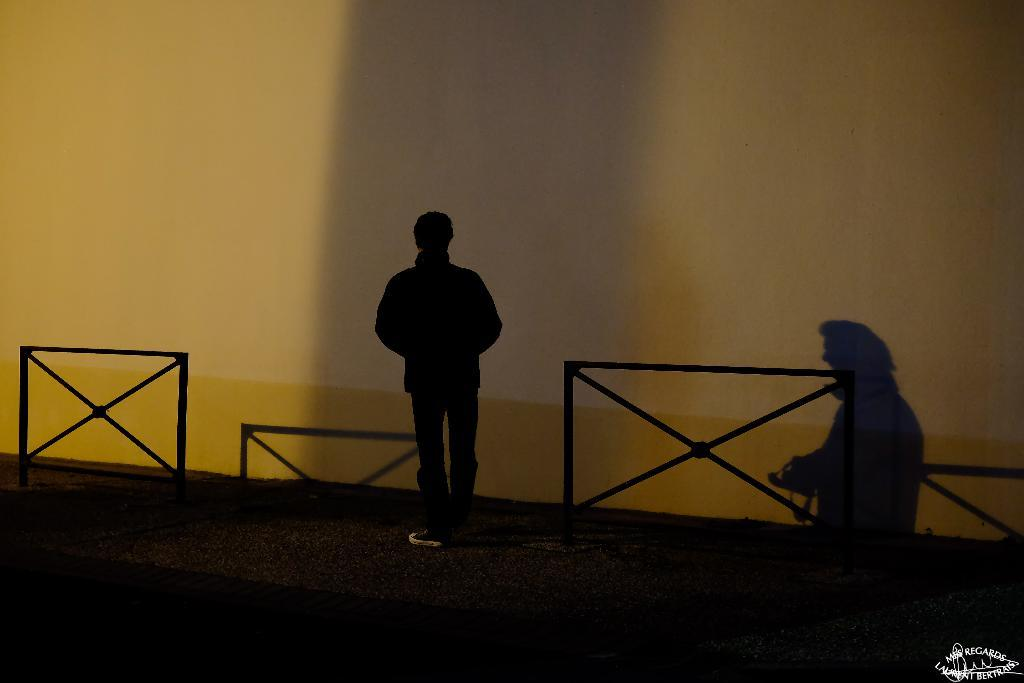What is the main subject of the image? There is a person standing in the image. What is the person wearing? The person is wearing a black dress. What can be seen in the background of the image? There is a fence in the image. What else is visible in the image? There is a shadow on the wall in the image. What type of pencil can be seen coiled around the person's arm in the image? There is no pencil or coil present in the image. How many spoons are visible in the person's hand in the image? There are no spoons visible in the person's hand in the image. 